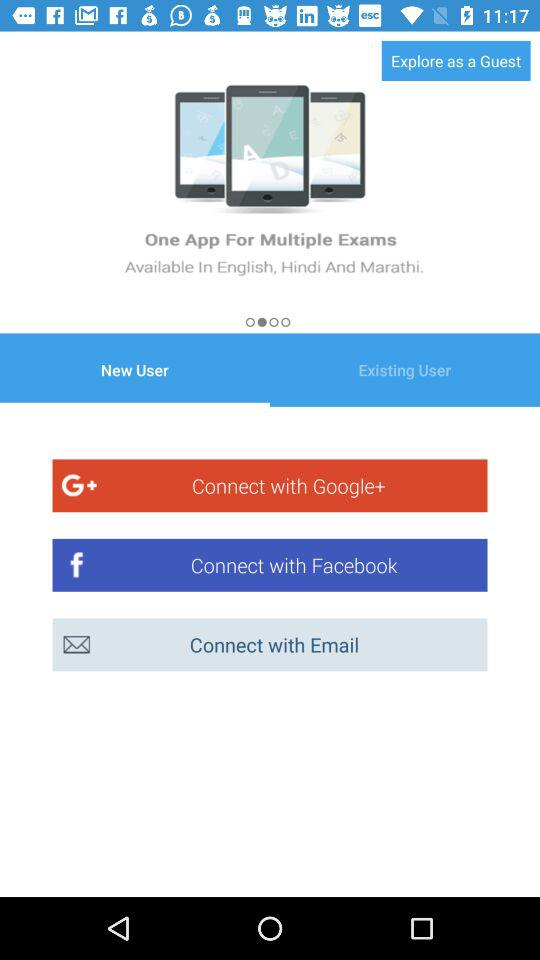What accounts can I use to log in? You can log in with "Google+", "Facebook" and "Email". 